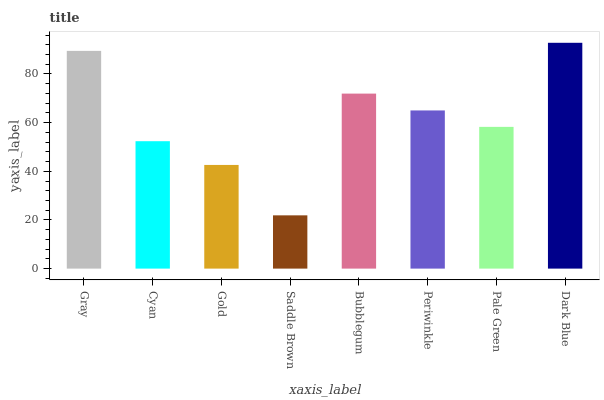Is Cyan the minimum?
Answer yes or no. No. Is Cyan the maximum?
Answer yes or no. No. Is Gray greater than Cyan?
Answer yes or no. Yes. Is Cyan less than Gray?
Answer yes or no. Yes. Is Cyan greater than Gray?
Answer yes or no. No. Is Gray less than Cyan?
Answer yes or no. No. Is Periwinkle the high median?
Answer yes or no. Yes. Is Pale Green the low median?
Answer yes or no. Yes. Is Pale Green the high median?
Answer yes or no. No. Is Gold the low median?
Answer yes or no. No. 